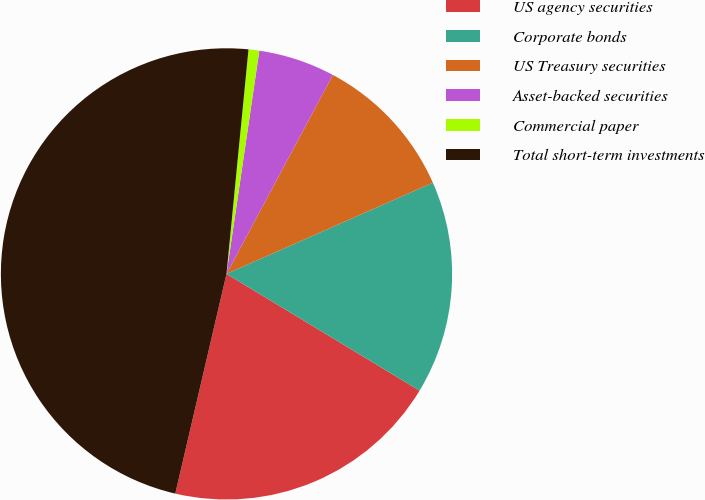<chart> <loc_0><loc_0><loc_500><loc_500><pie_chart><fcel>US agency securities<fcel>Corporate bonds<fcel>US Treasury securities<fcel>Asset-backed securities<fcel>Commercial paper<fcel>Total short-term investments<nl><fcel>19.99%<fcel>15.28%<fcel>10.56%<fcel>5.49%<fcel>0.77%<fcel>47.91%<nl></chart> 